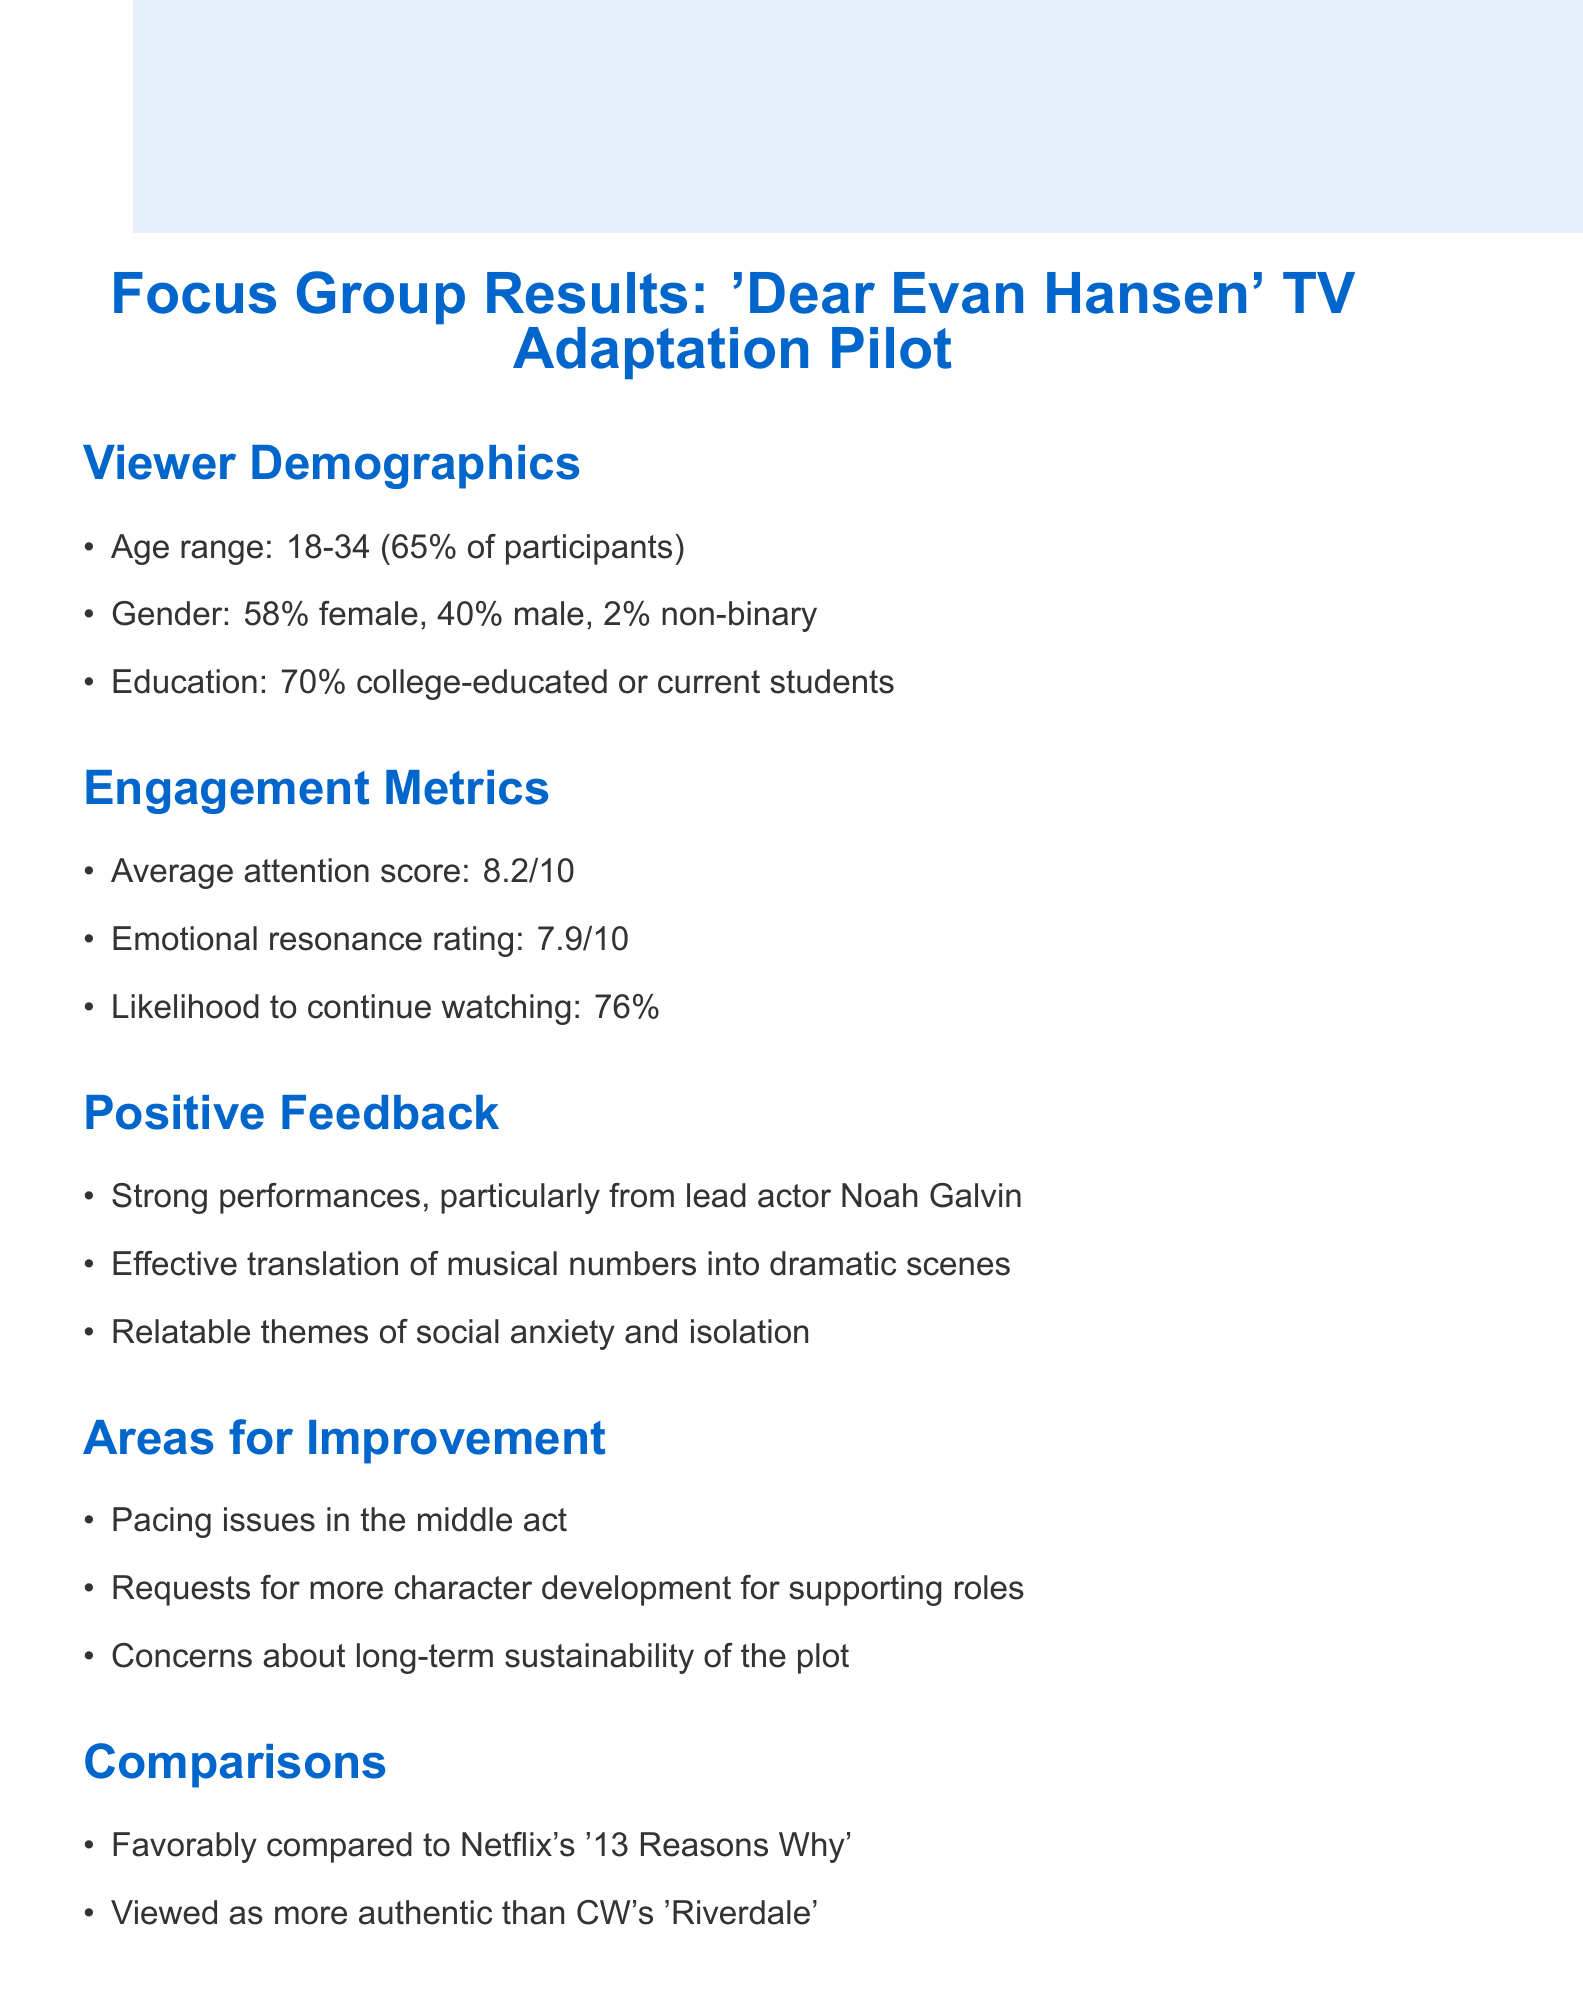what is the average attention score? The average attention score is provided in the engagement metrics section of the document, which states it is 8.2 out of 10.
Answer: 8.2/10 what percentage of participants are in the 18-34 age range? The document specifies that 65% of the focus group participants fall within the 18-34 age range.
Answer: 65% who is particularly noted for strong performances? The document highlights Noah Galvin as the lead actor who delivered strong performances according to the feedback.
Answer: Noah Galvin what are viewers concerned about regarding the plot? The document lists concerns about long-term sustainability of the plot as one of the areas for improvement mentioned by the focus group.
Answer: long-term sustainability which network aligns well with the show's target demographic? The document mentions that the show has a strong alignment with Freeform's young adult demographic.
Answer: Freeform what is the emotional resonance rating given by the focus group? The emotional resonance rating provided in the engagement metrics section of the document is a score of 7.9 out of 10.
Answer: 7.9/10 which series is 'Dear Evan Hansen' favorably compared to? The focus group favorably compared 'Dear Evan Hansen' to Netflix's '13 Reasons Why' according to the comparisons section of the document.
Answer: 13 Reasons Why what request was made regarding supporting roles? The document states that there were requests for more character development for supporting roles as part of the feedback.
Answer: more character development 